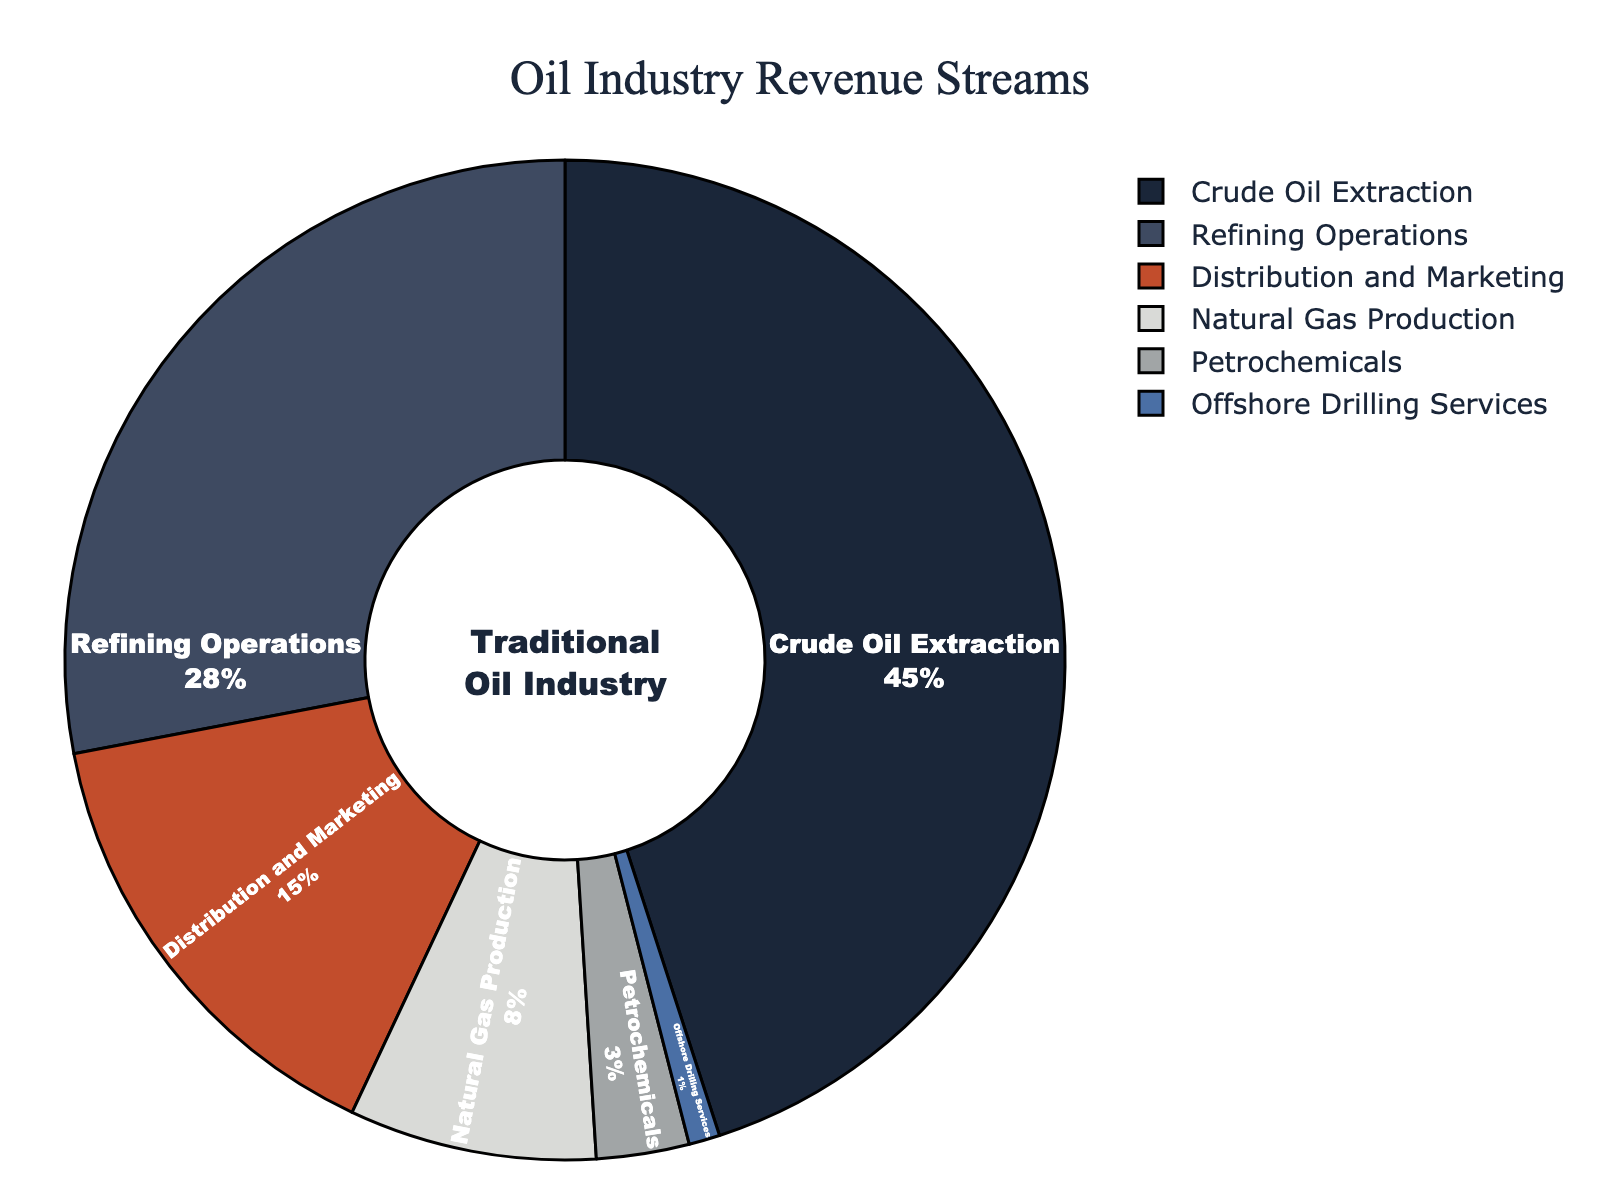What percentage of revenue comes from the combination of Natural Gas Production and Petrochemicals? The percentage of revenue from Natural Gas Production is 8%, and from Petrochemicals is 3%. Adding these together: 8 + 3 = 11%.
Answer: 11% Which revenue stream contributes the least to the overall revenue? By observing the figure, the smallest segment corresponds to Offshore Drilling Services with 1%.
Answer: Offshore Drilling Services Is the revenue from Refining Operations greater than the revenue from Distribution and Marketing? The revenue from Refining Operations is 28%, whereas from Distribution and Marketing, it is 15%. Comparing these: 28% is greater than 15%.
Answer: Yes What is the difference in revenue percentage between Crude Oil Extraction and Refining Operations? The percentage of revenue from Crude Oil Extraction is 45%, and from Refining Operations is 28%. The difference is: 45 - 28 = 17%.
Answer: 17% If you sum up the revenue percentages from Crude Oil Extraction, Refining Operations, and Distribution and Marketing, what will be the total? The percentages are: Crude Oil Extraction (45%), Refining Operations (28%), and Distribution and Marketing (15%). Adding these: 45 + 28 + 15 = 88%.
Answer: 88% Which two revenue streams together represent less than 10% of the total revenue? Observing the figure, Natural Gas Production (8%) and Petrochemicals (3%) together are 11%, which is more than 10%. However, Petrochemicals (3%) and Offshore Drilling Services (1%) together make: 3 + 1 = 4%, which is less than 10%.
Answer: Petrochemicals and Offshore Drilling Services 